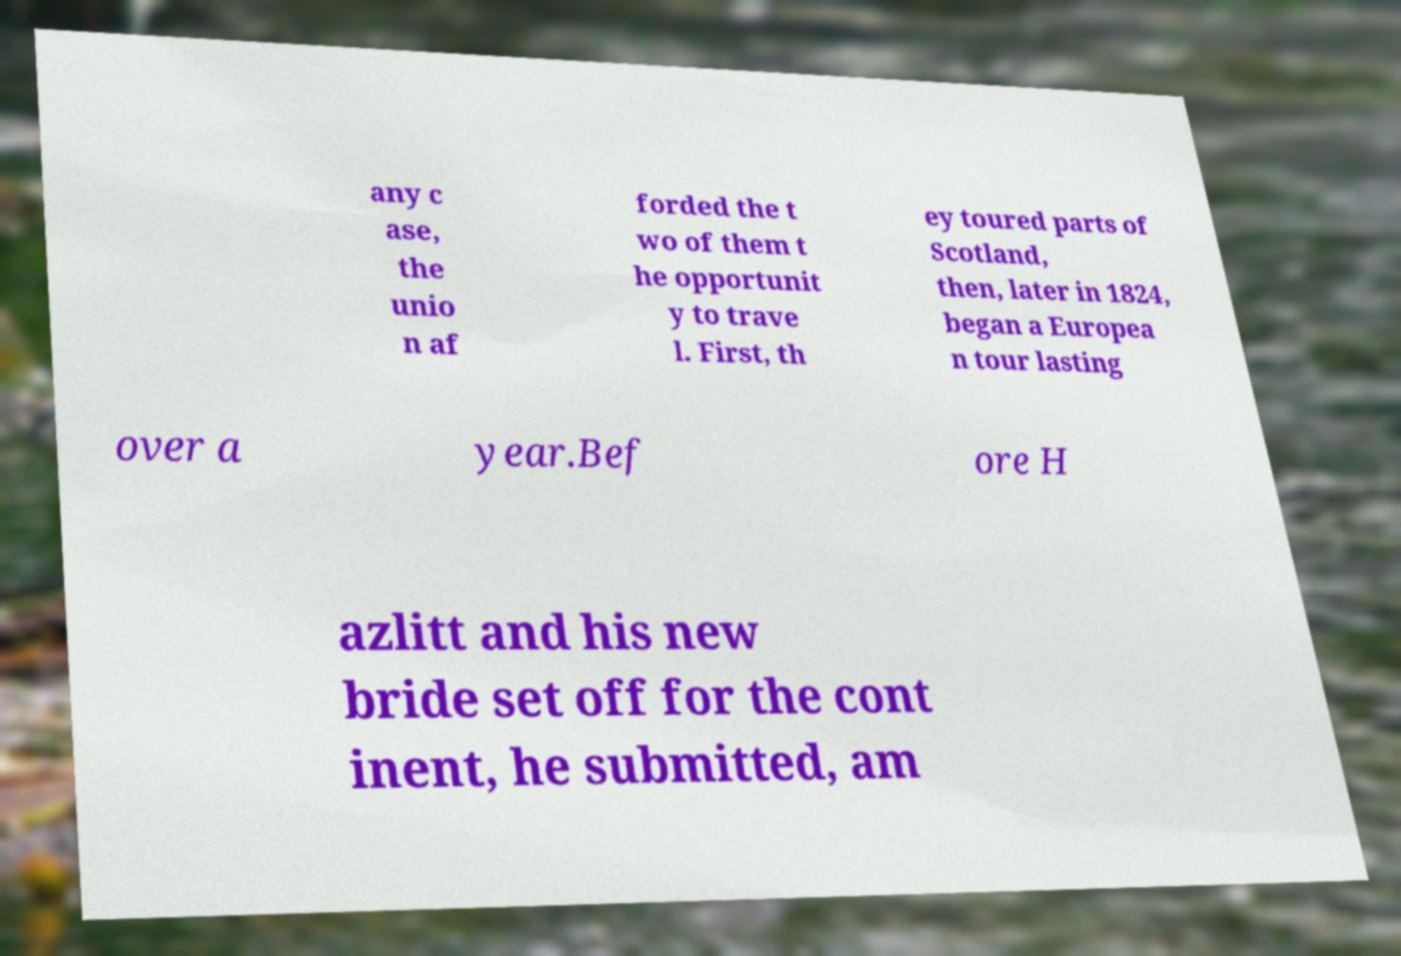For documentation purposes, I need the text within this image transcribed. Could you provide that? any c ase, the unio n af forded the t wo of them t he opportunit y to trave l. First, th ey toured parts of Scotland, then, later in 1824, began a Europea n tour lasting over a year.Bef ore H azlitt and his new bride set off for the cont inent, he submitted, am 